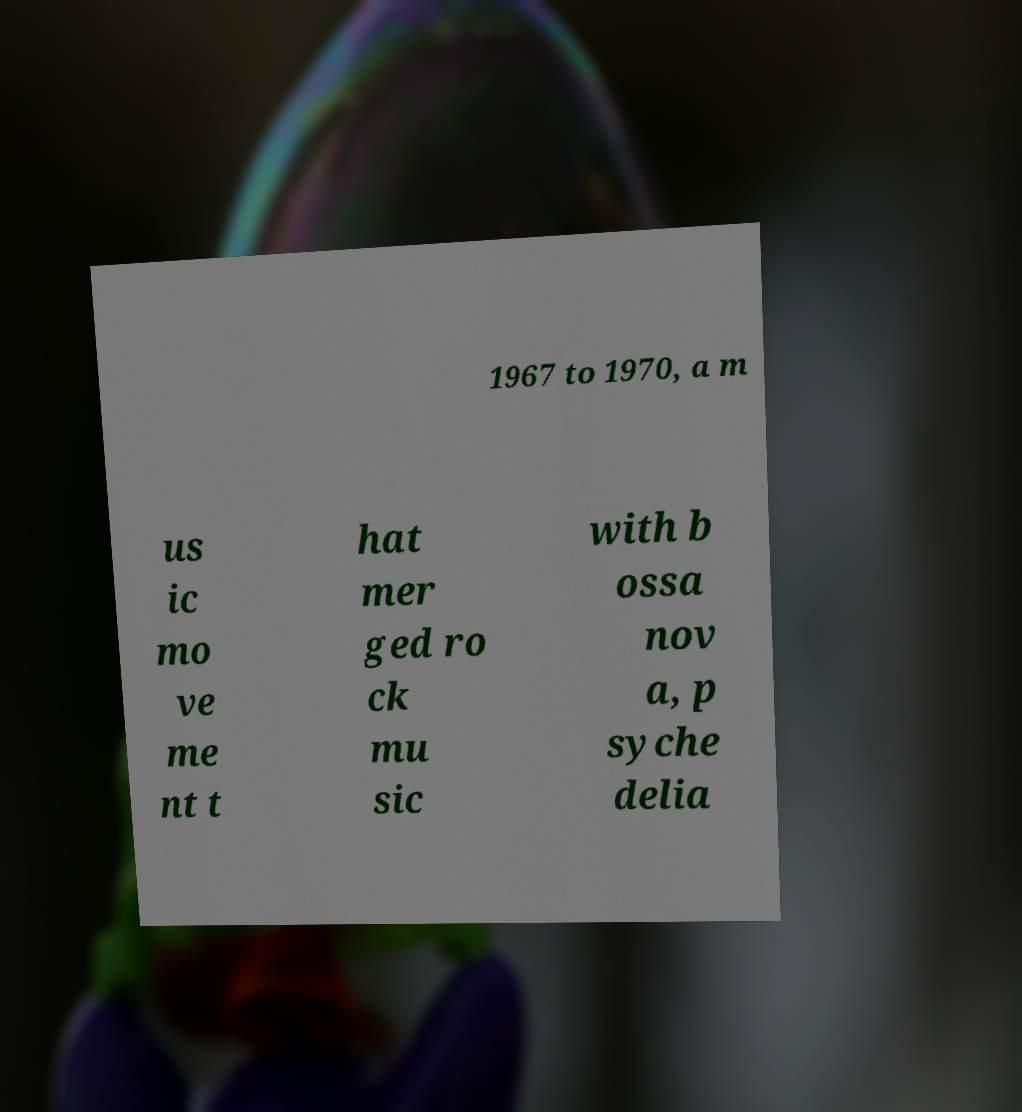Please identify and transcribe the text found in this image. 1967 to 1970, a m us ic mo ve me nt t hat mer ged ro ck mu sic with b ossa nov a, p syche delia 